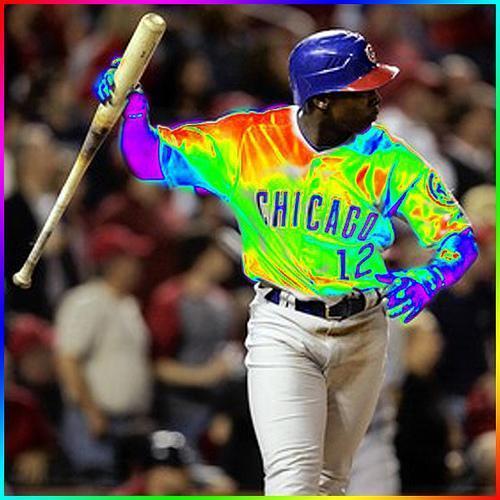How many people can be seen?
Give a very brief answer. 4. How many white computer mice are in the image?
Give a very brief answer. 0. 